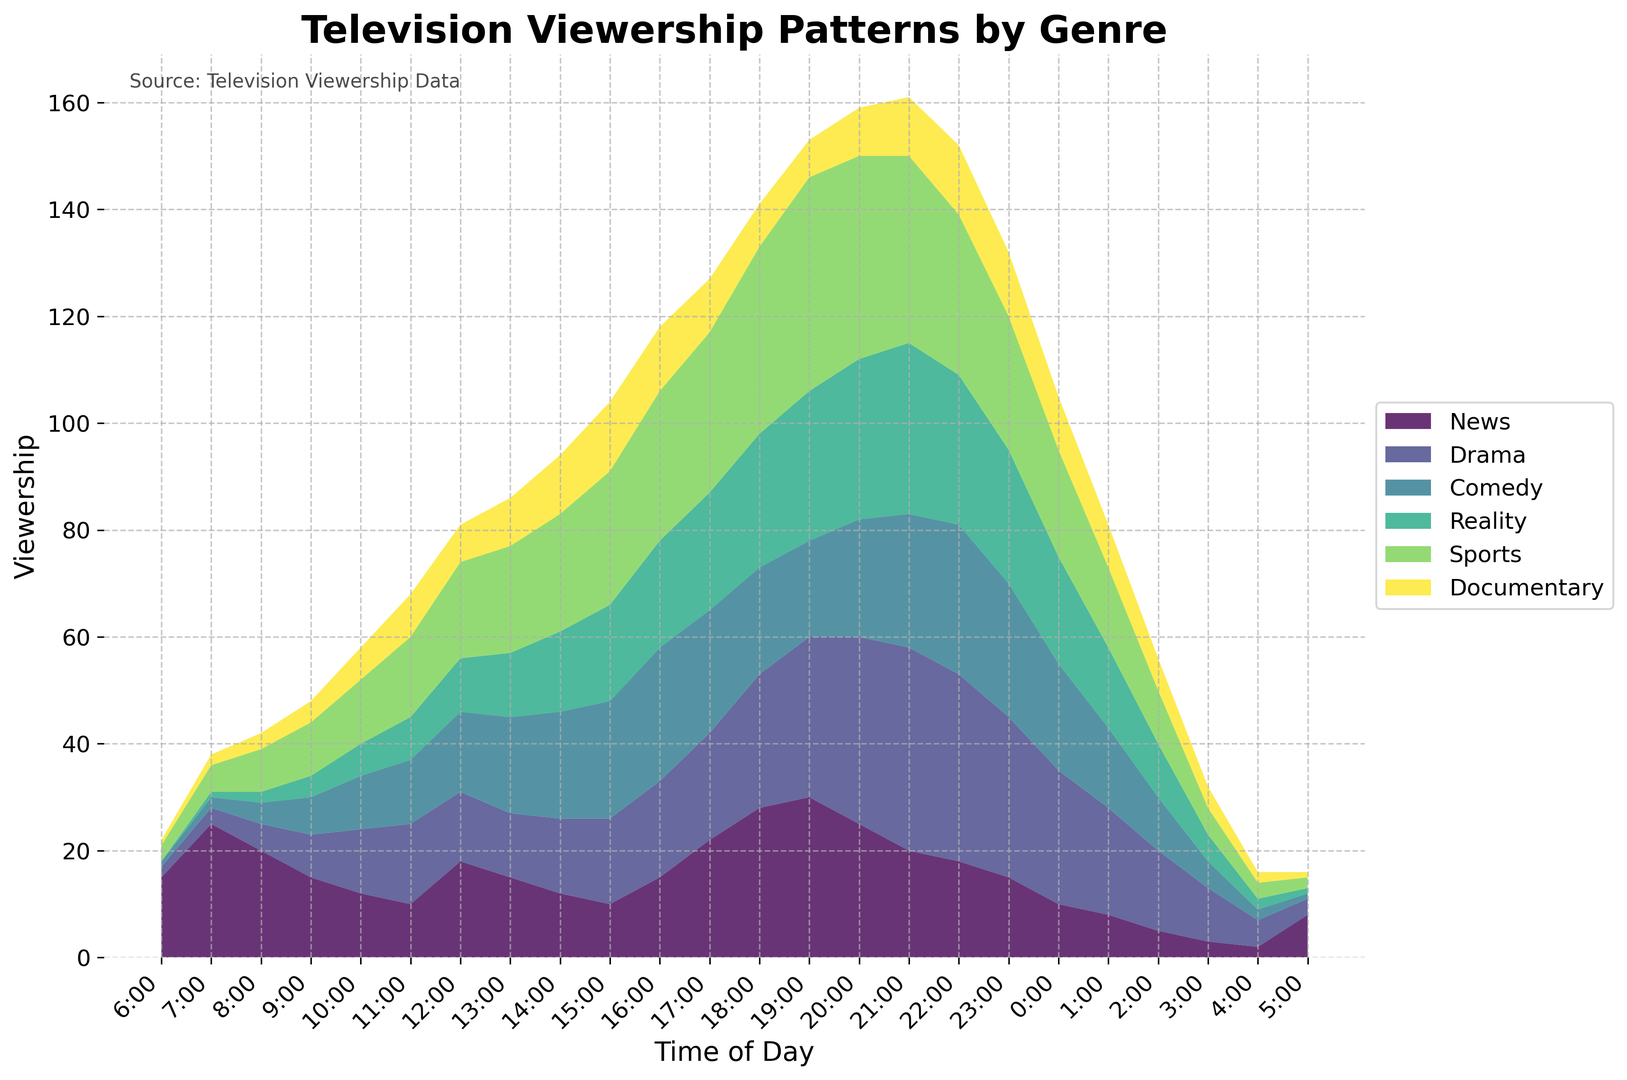Which genre has the highest viewership at 7:00? At 7:00, the highest viewership is observed in the "News" genre. This can be seen by comparing the heights of the areas for each genre at 7:00, where the News section is at its peak.
Answer: News By how much does the viewership of Documentary increase from 8:00 to 10:00? At 8:00, the Documentary viewership is 3 and at 10:00 it is 6. The increase is calculated as 6 - 3 = 3.
Answer: 3 Which genre's viewership shows a peak around 20:00? Around 20:00, the Drama viewership can be seen peaking higher compared to other genres by visually inspecting the highest point at around this time.
Answer: Drama What is the total viewership at 14:00? To find the total viewership at 14:00, sum up the values of all genres: News (12), Drama (14), Comedy (20), Reality (15), Sports (22), Documentary (11), which totals to 12 + 14 + 20 + 15 + 22 + 11 = 94.
Answer: 94 Which genre has the least viewership between 0:00 and 2:00? By observing the areas on the chart between 0:00 and 2:00, Drama has the lowest viewership values consistently compared to other genres in this time window.
Answer: Documentary Between 18:00 and 19:00, by how much does the viewership of Comedy decrease? The viewership for Comedy at 18:00 is 20 and at 19:00 is 18. The decrease is calculated as 20 - 18 = 2.
Answer: 2 Which genre's viewership appears to be the most stable throughout the day? By analyzing the chart, the Reality genre shows a relatively stable viewership with less fluctuation compared to other genres over the entire 24-hour period.
Answer: Reality At what time does the Sports genre first show a significant rise in viewership? Sports viewership first shows a significant rise at 8:00, where it jumps from 5 at 7:00 to 8 at 8:00 and continues to increase steadily afterwards.
Answer: 8:00 How does the Comedy viewership at 6:00 compare to the Drama viewership at the same time? At 6:00, Comedy has a viewership of 1, while Drama has a viewership of 2. Therefore, Comedy viewership is less than Drama viewership at this time.
Answer: Less What is the overall trend in News viewership over the course of the day? The News viewership shows a trend of being high early in the day, peaking around 7:00, and then generally decreasing throughout the day with minor fluctuations, before hitting a minimum late at night.
Answer: Decreasing 